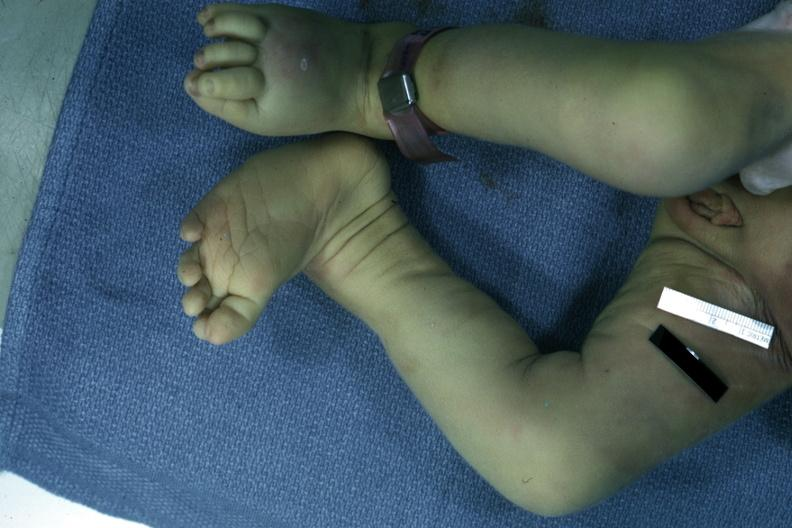what left club foot?
Answer the question using a single word or phrase. Autopsy 